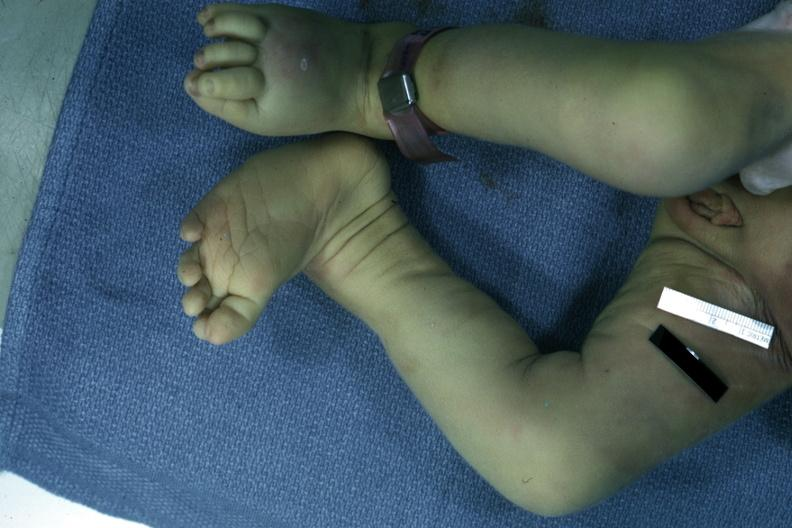what left club foot?
Answer the question using a single word or phrase. Autopsy 